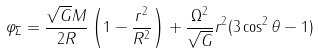Convert formula to latex. <formula><loc_0><loc_0><loc_500><loc_500>\varphi _ { \Sigma } = \frac { \sqrt { G } M } { 2 R } \left ( 1 - \frac { r ^ { 2 } } { R ^ { 2 } } \right ) + \frac { \Omega ^ { 2 } } { \sqrt { G } } r ^ { 2 } ( 3 \cos ^ { 2 } \theta - 1 )</formula> 